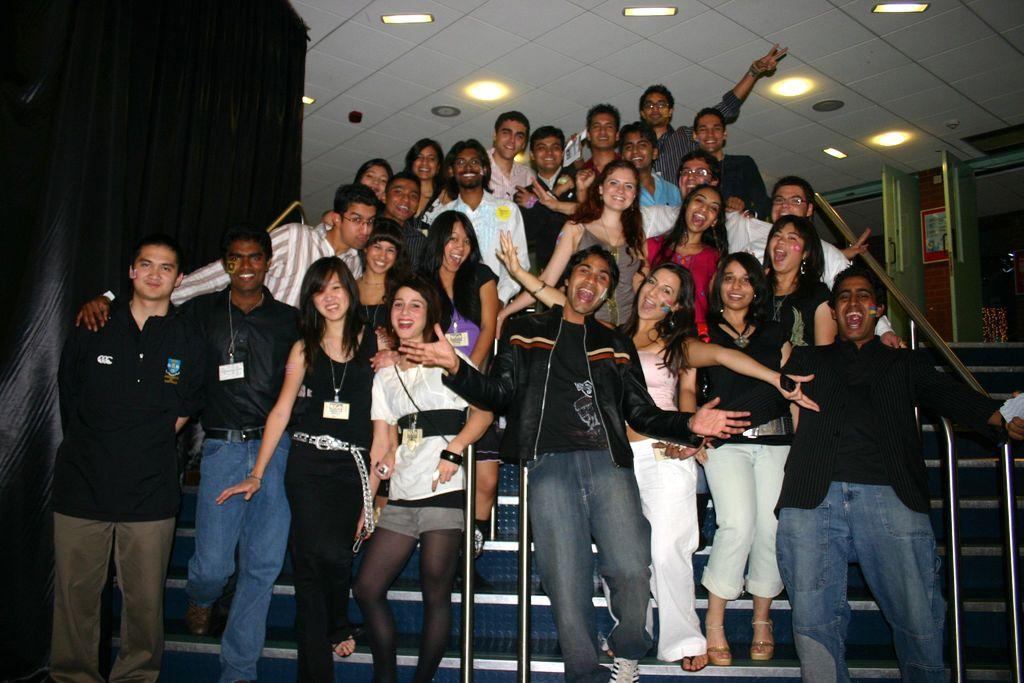What is happening with the group of people in the image? The people are standing and posing for the picture. What type of architectural feature is present in the image? There is a false ceiling in the image. What is special about the false ceiling? The false ceiling has lights. What material can be seen in the image? There are metal objects in the image. What type of frame is visible around the group of people in the image? There is no frame visible around the group of people in the image. Can you see a cannon in the image? There is no cannon present in the image. 